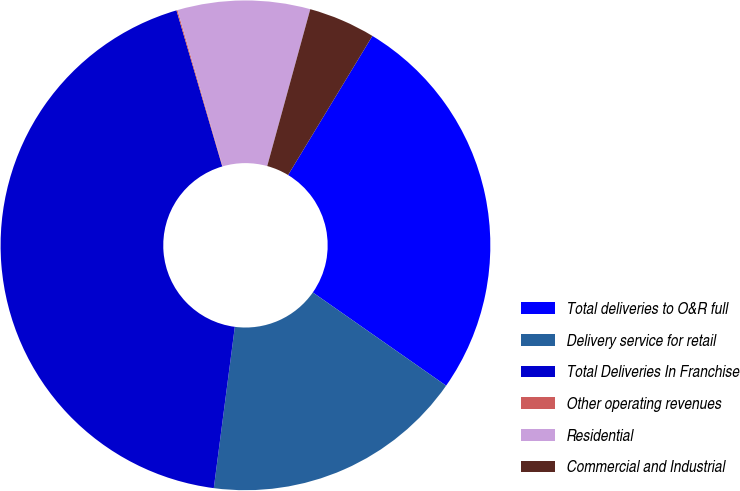<chart> <loc_0><loc_0><loc_500><loc_500><pie_chart><fcel>Total deliveries to O&R full<fcel>Delivery service for retail<fcel>Total Deliveries In Franchise<fcel>Other operating revenues<fcel>Residential<fcel>Commercial and Industrial<nl><fcel>26.04%<fcel>17.35%<fcel>43.39%<fcel>0.07%<fcel>8.74%<fcel>4.41%<nl></chart> 